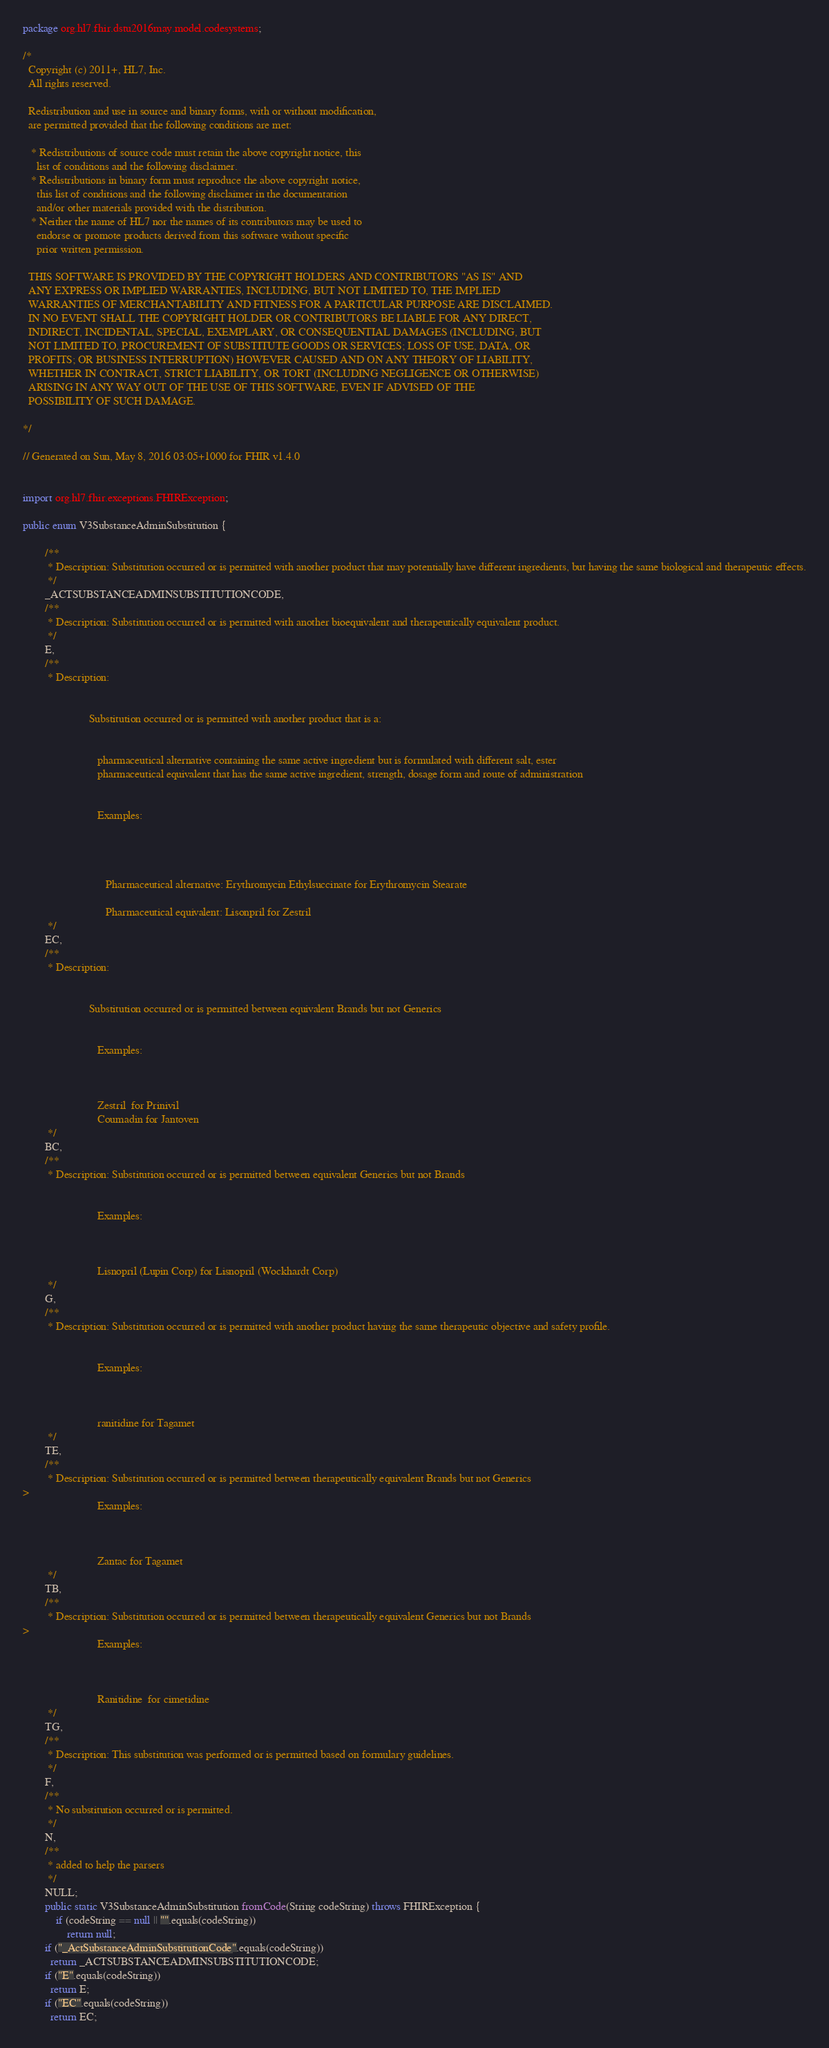Convert code to text. <code><loc_0><loc_0><loc_500><loc_500><_Java_>package org.hl7.fhir.dstu2016may.model.codesystems;

/*
  Copyright (c) 2011+, HL7, Inc.
  All rights reserved.
  
  Redistribution and use in source and binary forms, with or without modification, 
  are permitted provided that the following conditions are met:
  
   * Redistributions of source code must retain the above copyright notice, this 
     list of conditions and the following disclaimer.
   * Redistributions in binary form must reproduce the above copyright notice, 
     this list of conditions and the following disclaimer in the documentation 
     and/or other materials provided with the distribution.
   * Neither the name of HL7 nor the names of its contributors may be used to 
     endorse or promote products derived from this software without specific 
     prior written permission.
  
  THIS SOFTWARE IS PROVIDED BY THE COPYRIGHT HOLDERS AND CONTRIBUTORS "AS IS" AND 
  ANY EXPRESS OR IMPLIED WARRANTIES, INCLUDING, BUT NOT LIMITED TO, THE IMPLIED 
  WARRANTIES OF MERCHANTABILITY AND FITNESS FOR A PARTICULAR PURPOSE ARE DISCLAIMED. 
  IN NO EVENT SHALL THE COPYRIGHT HOLDER OR CONTRIBUTORS BE LIABLE FOR ANY DIRECT, 
  INDIRECT, INCIDENTAL, SPECIAL, EXEMPLARY, OR CONSEQUENTIAL DAMAGES (INCLUDING, BUT 
  NOT LIMITED TO, PROCUREMENT OF SUBSTITUTE GOODS OR SERVICES; LOSS OF USE, DATA, OR 
  PROFITS; OR BUSINESS INTERRUPTION) HOWEVER CAUSED AND ON ANY THEORY OF LIABILITY, 
  WHETHER IN CONTRACT, STRICT LIABILITY, OR TORT (INCLUDING NEGLIGENCE OR OTHERWISE) 
  ARISING IN ANY WAY OUT OF THE USE OF THIS SOFTWARE, EVEN IF ADVISED OF THE 
  POSSIBILITY OF SUCH DAMAGE.
  
*/

// Generated on Sun, May 8, 2016 03:05+1000 for FHIR v1.4.0


import org.hl7.fhir.exceptions.FHIRException;

public enum V3SubstanceAdminSubstitution {

        /**
         * Description: Substitution occurred or is permitted with another product that may potentially have different ingredients, but having the same biological and therapeutic effects.
         */
        _ACTSUBSTANCEADMINSUBSTITUTIONCODE, 
        /**
         * Description: Substitution occurred or is permitted with another bioequivalent and therapeutically equivalent product.
         */
        E, 
        /**
         * Description: 
                        

                        Substitution occurred or is permitted with another product that is a:

                        
                           pharmaceutical alternative containing the same active ingredient but is formulated with different salt, ester
                           pharmaceutical equivalent that has the same active ingredient, strength, dosage form and route of administration
                        
                        
                           Examples: 
                        

                        
                           
                              Pharmaceutical alternative: Erythromycin Ethylsuccinate for Erythromycin Stearate
                           
                              Pharmaceutical equivalent: Lisonpril for Zestril
         */
        EC, 
        /**
         * Description: 
                        

                        Substitution occurred or is permitted between equivalent Brands but not Generics

                        
                           Examples: 
                        

                        
                           Zestril  for Prinivil
                           Coumadin for Jantoven
         */
        BC, 
        /**
         * Description: Substitution occurred or is permitted between equivalent Generics but not Brands

                        
                           Examples: 
                        

                        
                           Lisnopril (Lupin Corp) for Lisnopril (Wockhardt Corp)
         */
        G, 
        /**
         * Description: Substitution occurred or is permitted with another product having the same therapeutic objective and safety profile.

                        
                           Examples: 
                        

                        
                           ranitidine for Tagamet
         */
        TE, 
        /**
         * Description: Substitution occurred or is permitted between therapeutically equivalent Brands but not Generics
>
                           Examples: 
                        

                        
                           Zantac for Tagamet
         */
        TB, 
        /**
         * Description: Substitution occurred or is permitted between therapeutically equivalent Generics but not Brands
>
                           Examples: 
                        

                        
                           Ranitidine  for cimetidine
         */
        TG, 
        /**
         * Description: This substitution was performed or is permitted based on formulary guidelines.
         */
        F, 
        /**
         * No substitution occurred or is permitted.
         */
        N, 
        /**
         * added to help the parsers
         */
        NULL;
        public static V3SubstanceAdminSubstitution fromCode(String codeString) throws FHIRException {
            if (codeString == null || "".equals(codeString))
                return null;
        if ("_ActSubstanceAdminSubstitutionCode".equals(codeString))
          return _ACTSUBSTANCEADMINSUBSTITUTIONCODE;
        if ("E".equals(codeString))
          return E;
        if ("EC".equals(codeString))
          return EC;</code> 